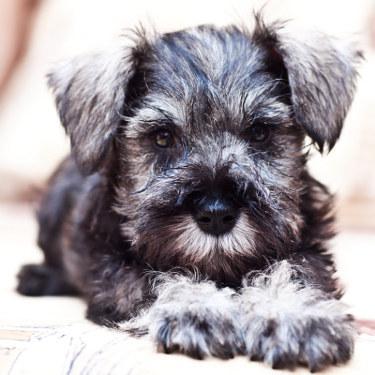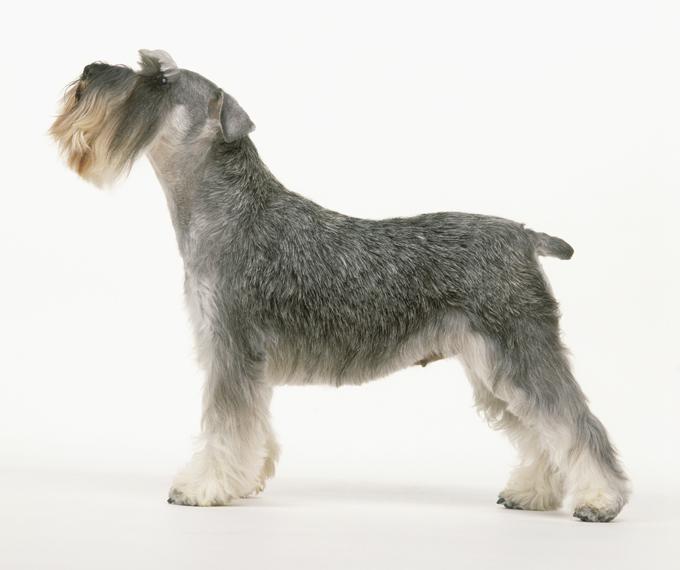The first image is the image on the left, the second image is the image on the right. Examine the images to the left and right. Is the description "The dog in the image on the right is shown as a side profile." accurate? Answer yes or no. Yes. 